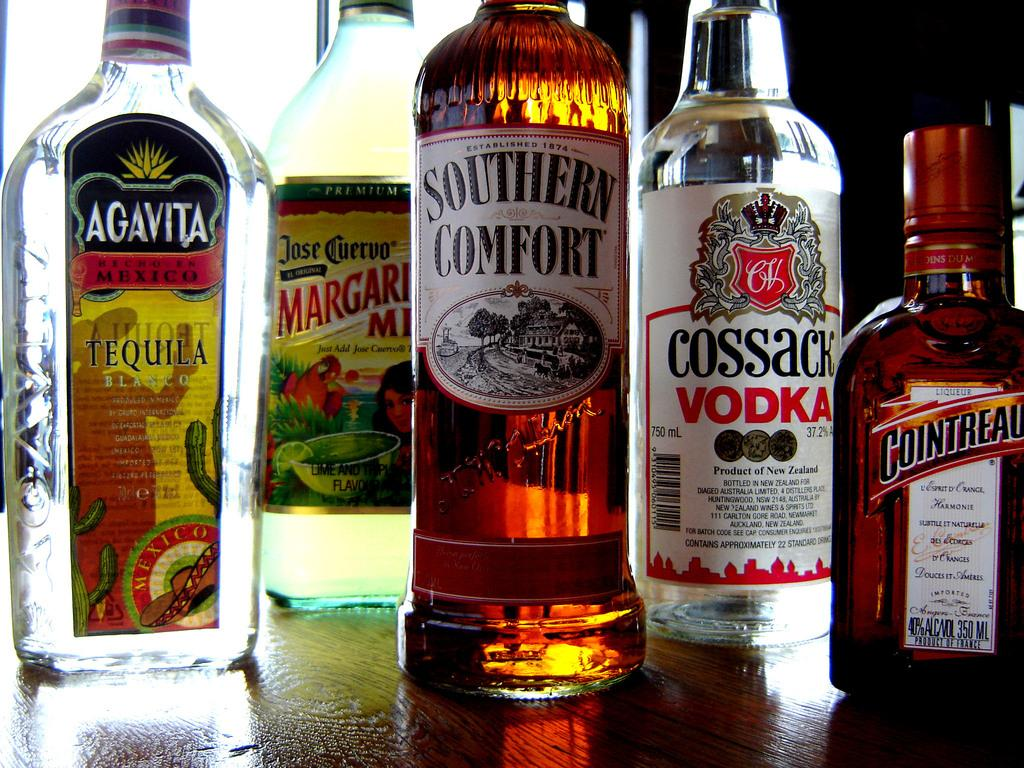<image>
Summarize the visual content of the image. Bottles of liquor, one of which is Southern Comfort 